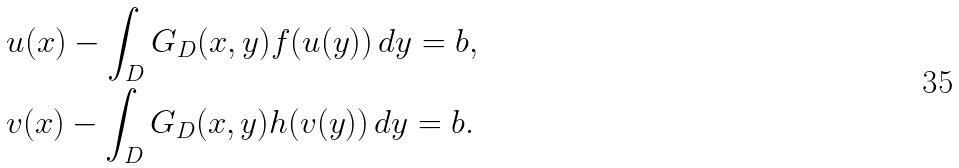<formula> <loc_0><loc_0><loc_500><loc_500>& u ( x ) - \int _ { D } G _ { D } ( x , y ) f ( u ( y ) ) \, d y = b , \\ & v ( x ) - \int _ { D } G _ { D } ( x , y ) h ( v ( y ) ) \, d y = b .</formula> 